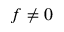Convert formula to latex. <formula><loc_0><loc_0><loc_500><loc_500>f \neq 0</formula> 